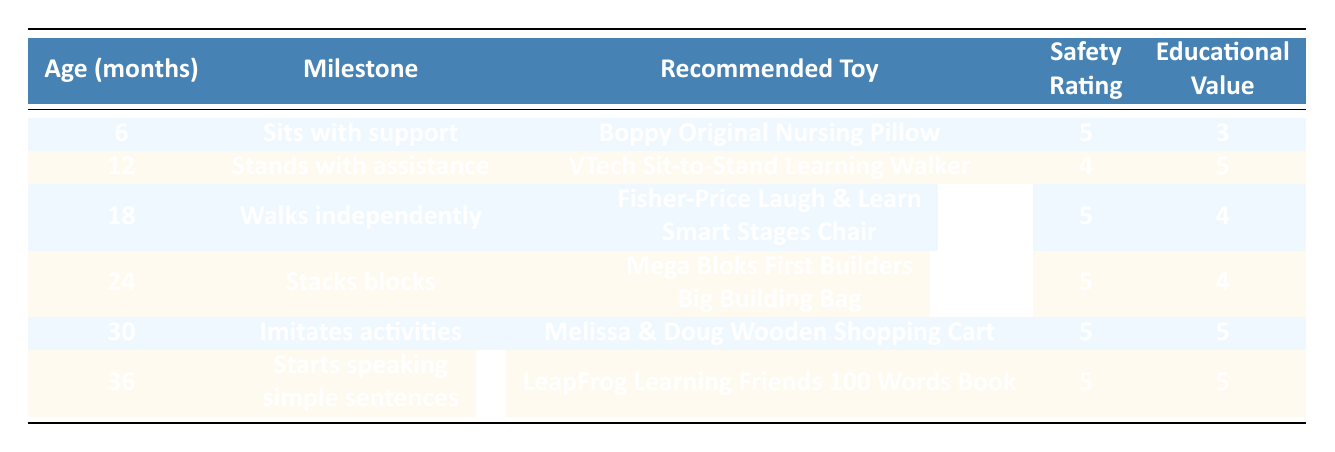What is the safety rating of the recommended toy for a 12-month-old? The safety rating for the recommended toy for a 12-month-old, which is the VTech Sit-to-Stand Learning Walker, is listed directly in the table.
Answer: 4 What milestone does a child typically achieve at 6 months? The table specifies that the milestone for a child at 6 months is "Sits with support."
Answer: Sits with support How many toys recommended for children aged 24 months have an educational value of 4? According to the table, both the Fisher-Price Laugh & Learn Smart Stages Chair and the Mega Bloks First Builders Big Building Bag have an educational value of 4. Only the Mega Bloks are for 24 months.
Answer: 1 Is the recommended toy for a 36-month-old considered safe? The LeapFrog Learning Friends 100 Words Book, recommended for a 36-month-old, has a safety rating of 5, indicating it is considered safe.
Answer: Yes What is the average educational value of the recommended toys from 6 to 36 months? The educational values for the toys are 3, 5, 4, 4, 5, and 5. Summing these gives 26. There are 6 toys, so the average educational value is 26/6 = approximately 4.33.
Answer: 4.33 Which toy has the highest educational value, and what age milestone does it correspond to? The toys with the highest educational value (5) are the Melissa & Doug Wooden Shopping Cart and the LeapFrog Learning Friends 100 Words Book. The wooden shopping cart corresponds to 30 months and the LeapFrog book corresponds to 36 months.
Answer: LeapFrog Learning Friends 100 Words Book; 36 months How many milestones are associated with toys that have a safety rating of 5? From the table, the toys associated with safety ratings of 5 are for ages 6, 18, 24, 30, and 36 months. Counting them gives a total of 5 milestones with a safety rating of 5.
Answer: 5 Do any of the recommended toys have a safety rating and educational value of 5? Yes, both the Melissa & Doug Wooden Shopping Cart and the LeapFrog Learning Friends 100 Words Book have a safety rating of 5 and an educational value of 5.
Answer: Yes What is the safety rating difference between the recommended toys for 12-month-olds and 30-month-olds? The safety rating for the 12-month-old toy (4) minus the safety rating for the 30-month-old toy (5) results in a difference of -1.
Answer: -1 